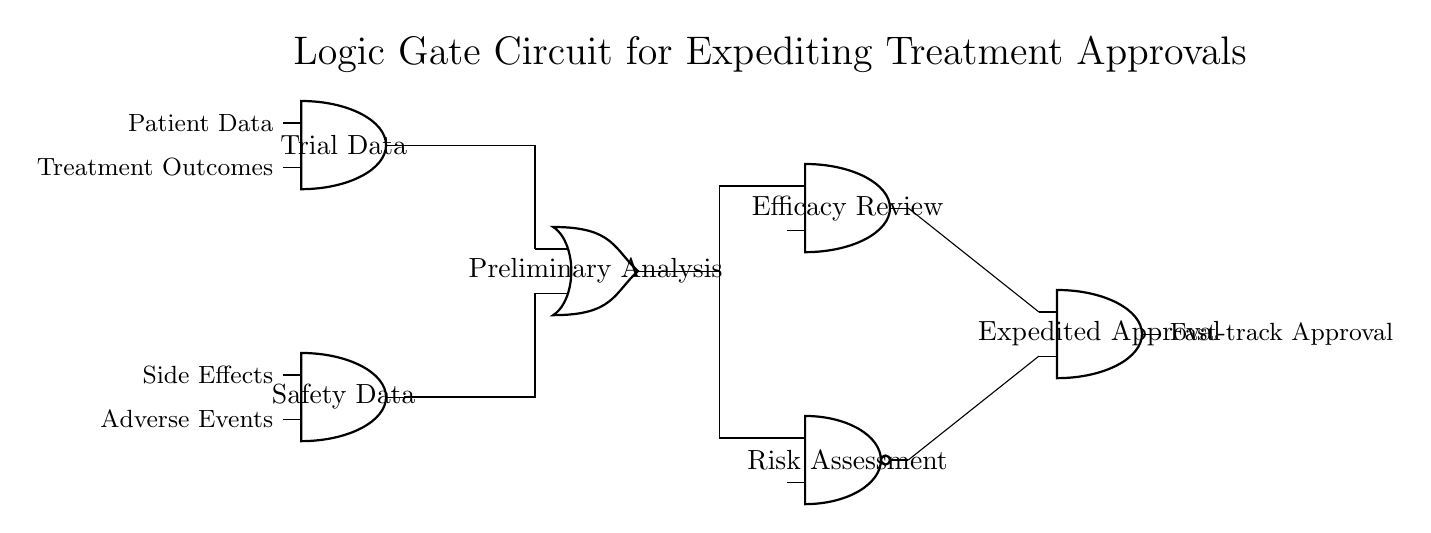What are the two main input types to the circuit? The two main inputs are "Trial Data" and "Safety Data," identified at the top of the circuit as the initial nodes.
Answer: Trial Data, Safety Data How many gates are utilized in this logic circuit? There are a total of five gates: two AND gates, one OR gate, one AND gate for efficacy review, and one NAND gate for risk assessment.
Answer: Five gates What type of gate is used for the risk assessment? The risk assessment is processed using a NAND gate, which is noted in the circuit diagram at the lower section.
Answer: NAND What is the final output of this circuit? The final output is labeled as "Expedited Approval," which is the result of processing the previous gate outputs.
Answer: Expedited Approval How many connections lead into the expedited approval gate? There are two connections leading into the expedited approval gate coming from the efficacy review AND gate and the risk assessment NAND gate.
Answer: Two connections What is the function of the preliminary analysis gate? The preliminary analysis gate serves as a processing point that evaluates inputs from trial and safety data before proceeding to further analysis.
Answer: Evaluate inputs Which data is associated with the patient from the input nodes? The patient-related data includes both "Patient Data" and "Treatment Outcomes" as indicated on the left side of the Trial Data gate.
Answer: Patient Data, Treatment Outcomes 